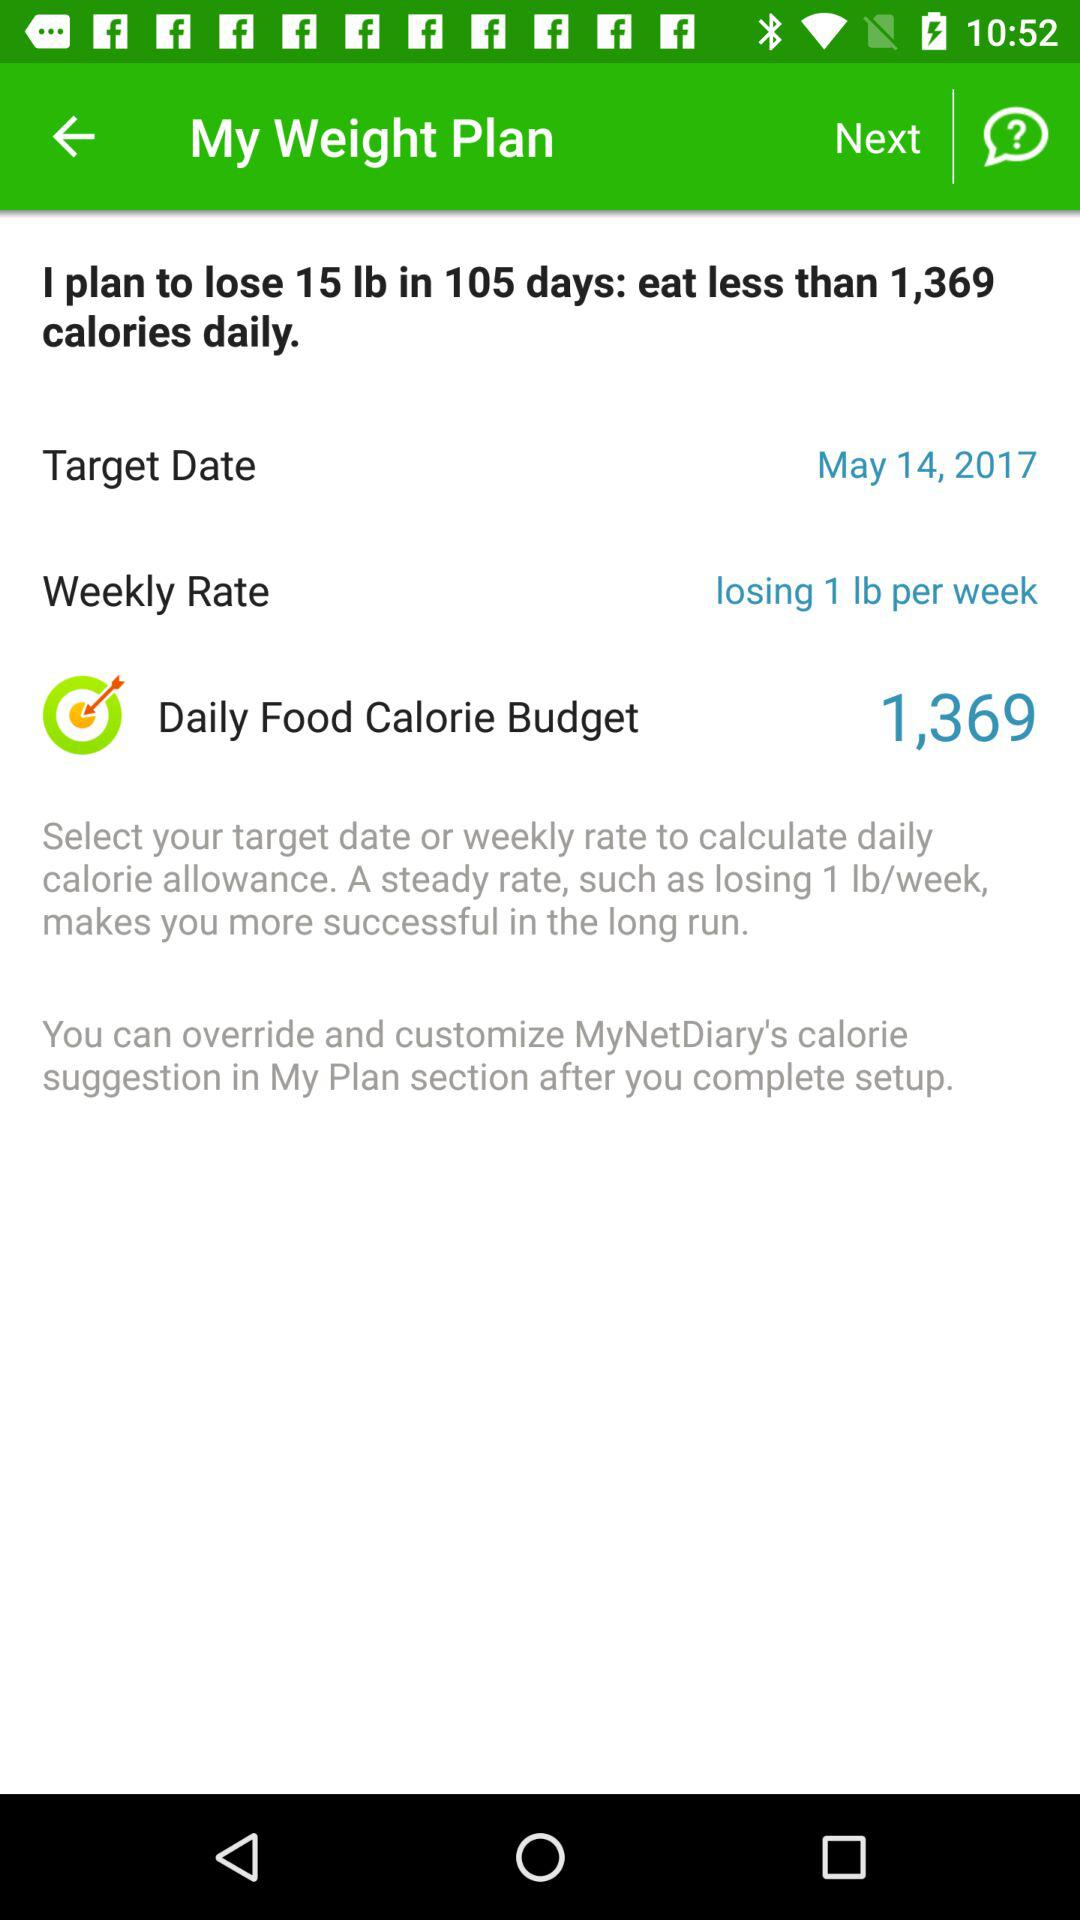What is the target date? The target date is May 14, 2017. 